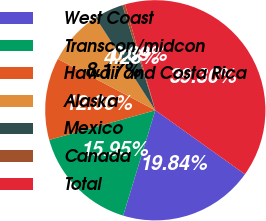<chart> <loc_0><loc_0><loc_500><loc_500><pie_chart><fcel>West Coast<fcel>Transcon/midcon<fcel>Hawaii and Costa Rica<fcel>Alaska<fcel>Mexico<fcel>Canada<fcel>Total<nl><fcel>19.84%<fcel>15.95%<fcel>12.06%<fcel>8.17%<fcel>4.28%<fcel>0.39%<fcel>39.29%<nl></chart> 